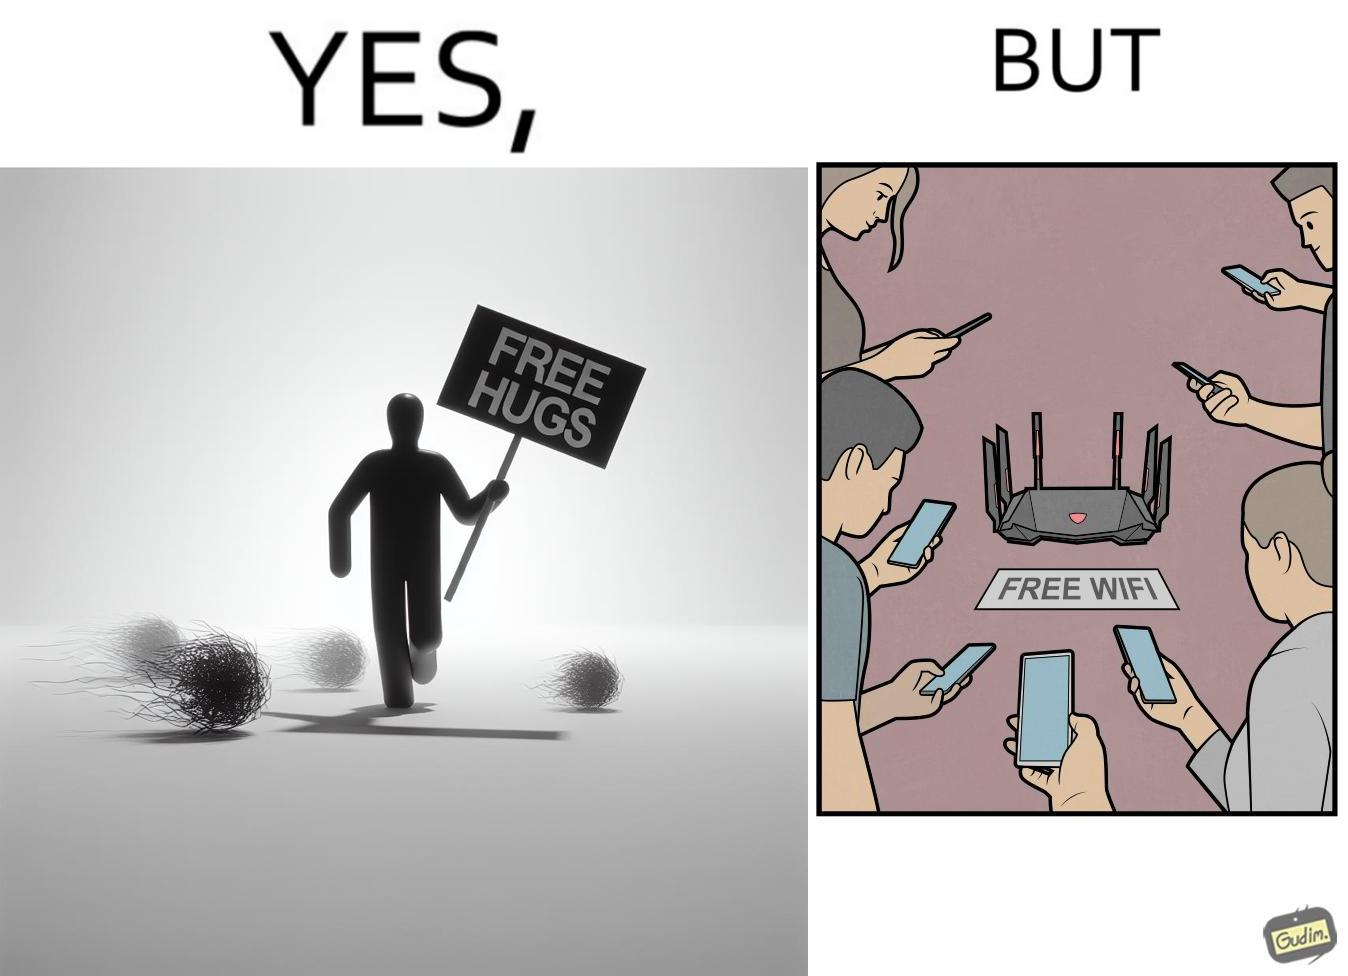Describe the contrast between the left and right parts of this image. In the left part of the image: a person standing alone holding a sign "Free Hugs". The tumbleweeds blowing in the wind further stress on the loneliness. In the right part of the image: A Wi-fi Router with the label "Free Wifi" in front of it, surrounded by people trying to connect to it on their mobile devices. 